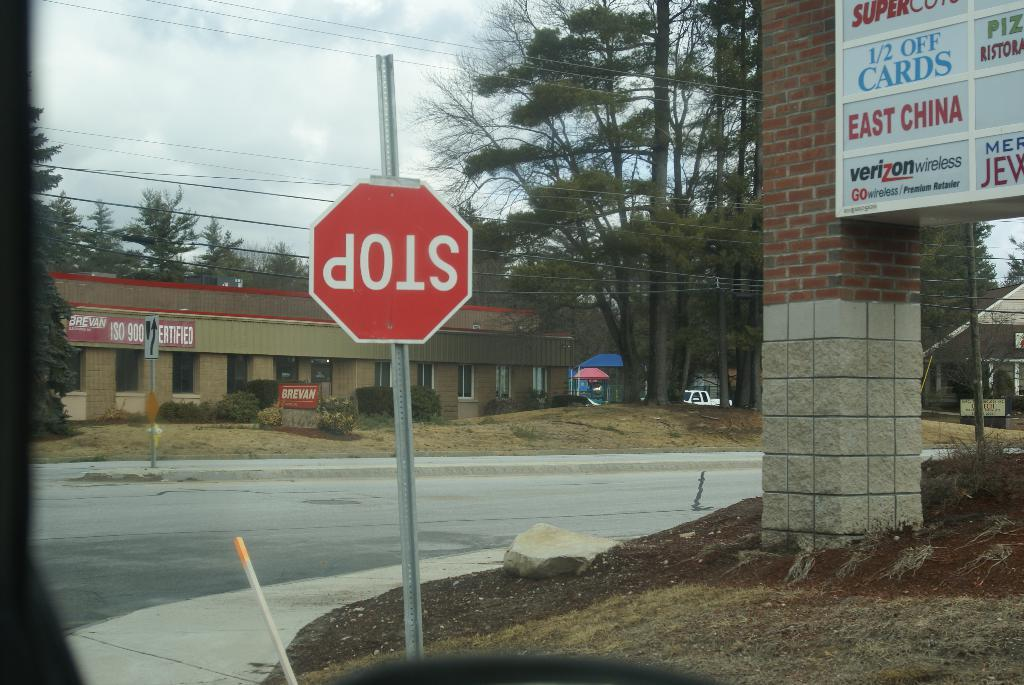<image>
Write a terse but informative summary of the picture. A street corner next to a mini mall contains a stop sign that is upside down. 